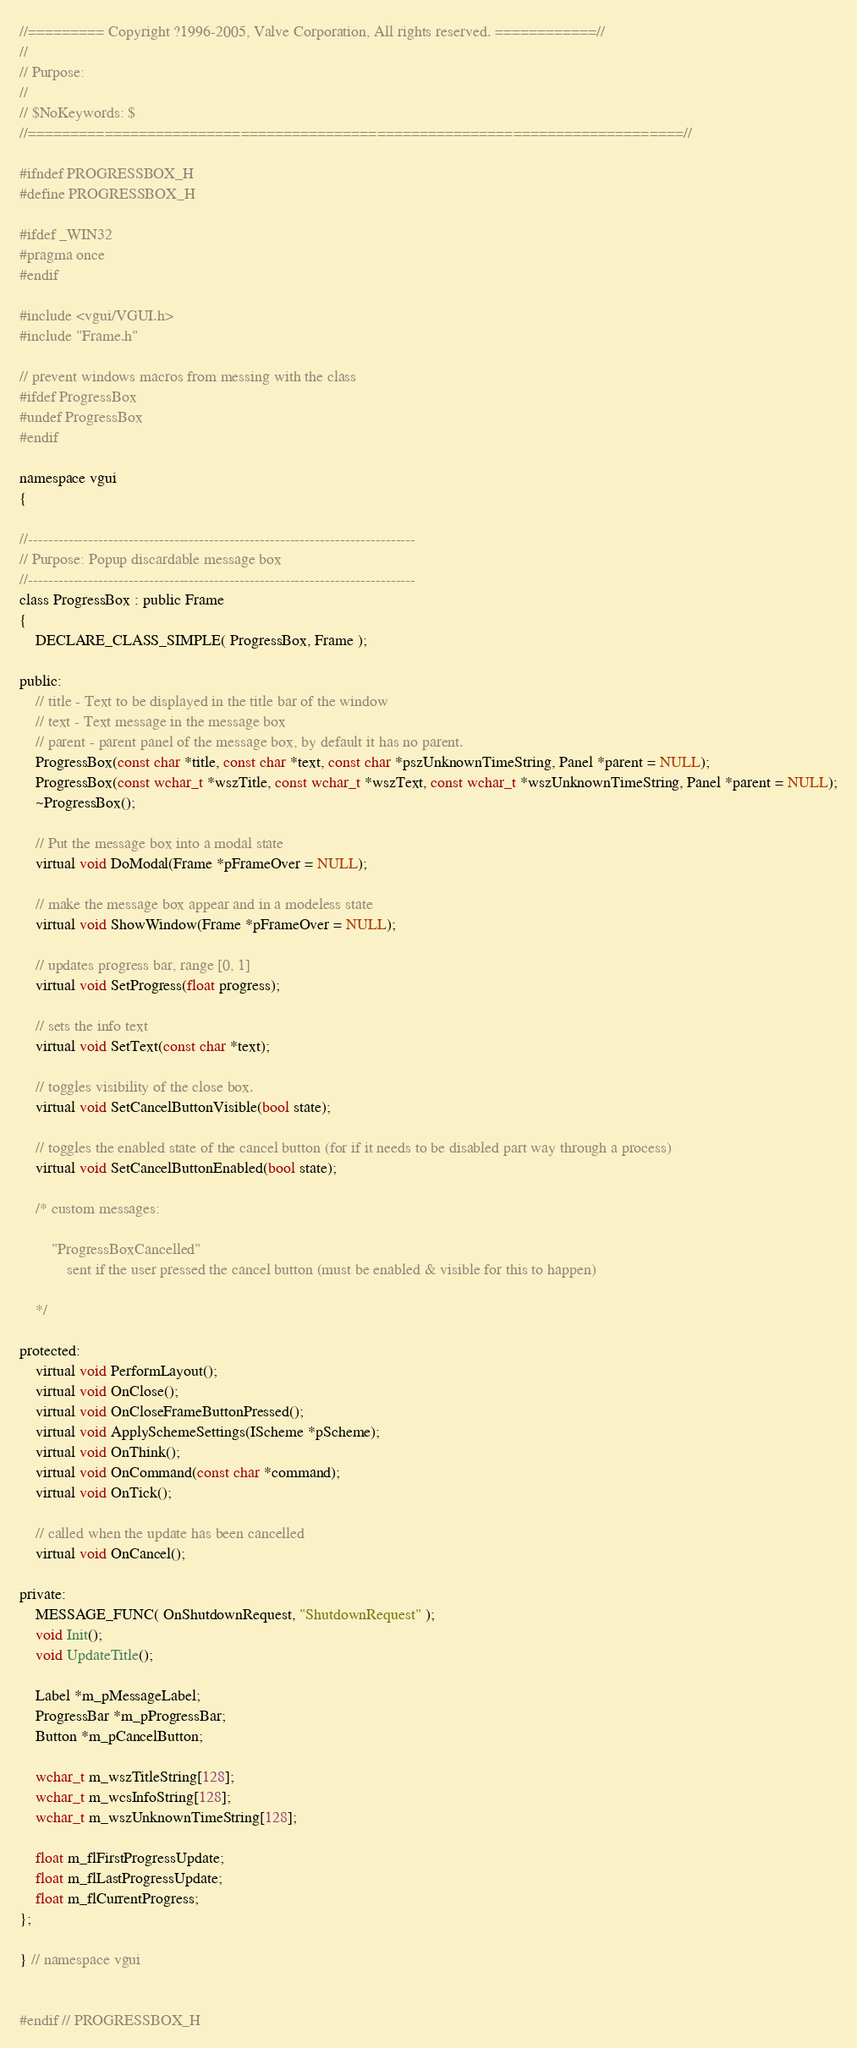<code> <loc_0><loc_0><loc_500><loc_500><_C_>//========= Copyright ?1996-2005, Valve Corporation, All rights reserved. ============//
//
// Purpose: 
//
// $NoKeywords: $
//=============================================================================//

#ifndef PROGRESSBOX_H
#define PROGRESSBOX_H

#ifdef _WIN32
#pragma once
#endif

#include <vgui/VGUI.h>
#include "Frame.h"

// prevent windows macros from messing with the class
#ifdef ProgressBox
#undef ProgressBox
#endif

namespace vgui
{

//-----------------------------------------------------------------------------
// Purpose: Popup discardable message box
//-----------------------------------------------------------------------------
class ProgressBox : public Frame
{
	DECLARE_CLASS_SIMPLE( ProgressBox, Frame );

public:
	// title - Text to be displayed in the title bar of the window
	// text - Text message in the message box
	// parent - parent panel of the message box, by default it has no parent.
	ProgressBox(const char *title, const char *text, const char *pszUnknownTimeString, Panel *parent = NULL);
	ProgressBox(const wchar_t *wszTitle, const wchar_t *wszText, const wchar_t *wszUnknownTimeString, Panel *parent = NULL);
	~ProgressBox();

	// Put the message box into a modal state
	virtual void DoModal(Frame *pFrameOver = NULL);

	// make the message box appear and in a modeless state
	virtual void ShowWindow(Frame *pFrameOver = NULL);

	// updates progress bar, range [0, 1]
	virtual void SetProgress(float progress);

	// sets the info text
	virtual void SetText(const char *text);

	// toggles visibility of the close box.
	virtual void SetCancelButtonVisible(bool state);

	// toggles the enabled state of the cancel button (for if it needs to be disabled part way through a process)
	virtual void SetCancelButtonEnabled(bool state);

	/* custom messages:

		"ProgressBoxCancelled"
			sent if the user pressed the cancel button (must be enabled & visible for this to happen)

	*/

protected:
	virtual void PerformLayout();
	virtual void OnClose();
	virtual void OnCloseFrameButtonPressed();
	virtual void ApplySchemeSettings(IScheme *pScheme);
	virtual void OnThink();
	virtual void OnCommand(const char *command);
	virtual void OnTick();

	// called when the update has been cancelled
	virtual void OnCancel();

private:
	MESSAGE_FUNC( OnShutdownRequest, "ShutdownRequest" );
	void Init();
	void UpdateTitle();

	Label *m_pMessageLabel;
	ProgressBar *m_pProgressBar;
	Button *m_pCancelButton;

	wchar_t m_wszTitleString[128];
	wchar_t m_wcsInfoString[128];
	wchar_t m_wszUnknownTimeString[128];

	float m_flFirstProgressUpdate;
	float m_flLastProgressUpdate;
	float m_flCurrentProgress;
};

} // namespace vgui


#endif // PROGRESSBOX_H
</code> 